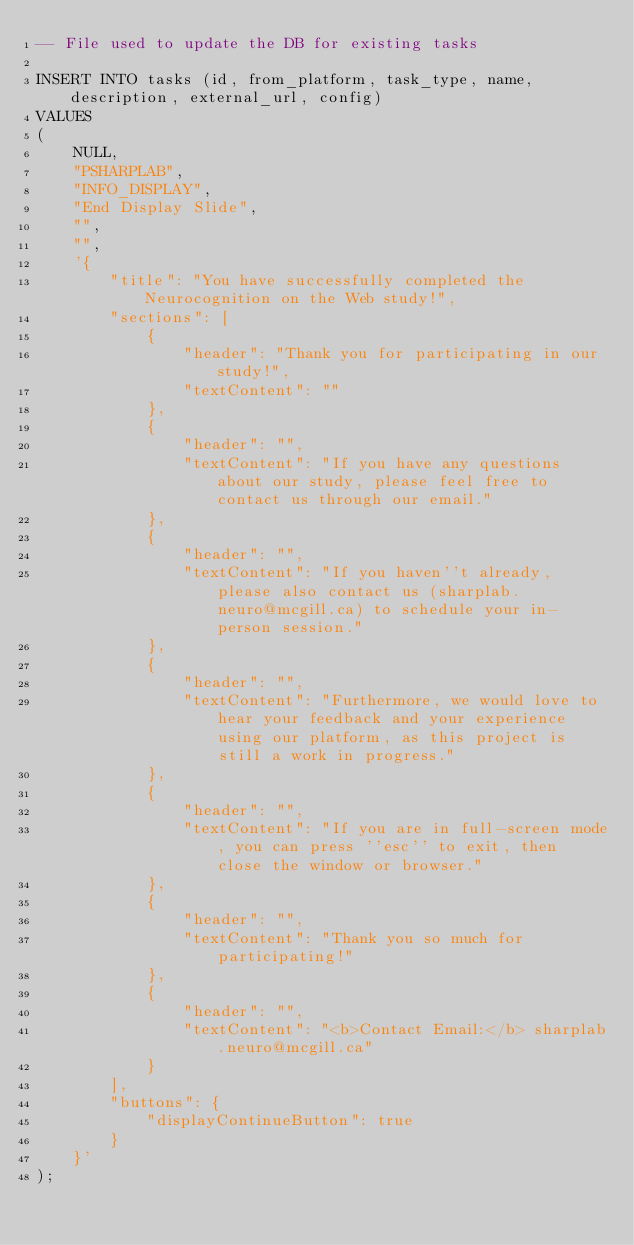Convert code to text. <code><loc_0><loc_0><loc_500><loc_500><_SQL_>-- File used to update the DB for existing tasks

INSERT INTO tasks (id, from_platform, task_type, name, description, external_url, config) 
VALUES
(
    NULL,
    "PSHARPLAB",
    "INFO_DISPLAY",
    "End Display Slide",
    "",
    "",
    '{
        "title": "You have successfully completed the Neurocognition on the Web study!",
        "sections": [
            {
                "header": "Thank you for participating in our study!",
                "textContent": ""
            },
            {
                "header": "",
                "textContent": "If you have any questions about our study, please feel free to contact us through our email."
            },
            {
                "header": "",
                "textContent": "If you haven''t already, please also contact us (sharplab.neuro@mcgill.ca) to schedule your in-person session."
            },
            {
                "header": "",
                "textContent": "Furthermore, we would love to hear your feedback and your experience using our platform, as this project is still a work in progress."
            },
            {
                "header": "",
                "textContent": "If you are in full-screen mode, you can press ''esc'' to exit, then close the window or browser."
            },
            {
                "header": "",
                "textContent": "Thank you so much for participating!"
            },
            {
                "header": "",
                "textContent": "<b>Contact Email:</b> sharplab.neuro@mcgill.ca"
            }
        ],
        "buttons": {
            "displayContinueButton": true
        }
    }'
);</code> 